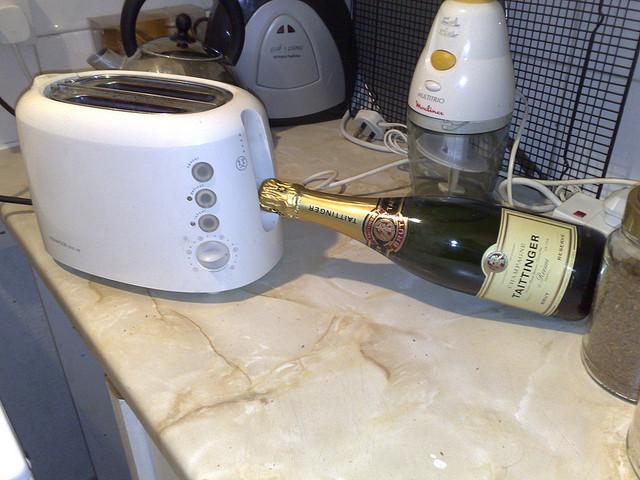What is the counter made of?
Write a very short answer. Marble. What room is this?
Concise answer only. Kitchen. What is the name of the wine?
Concise answer only. Taittinger. What type of event was this?
Keep it brief. Party. What kinds of drinks are on the table?
Write a very short answer. Champagne. 